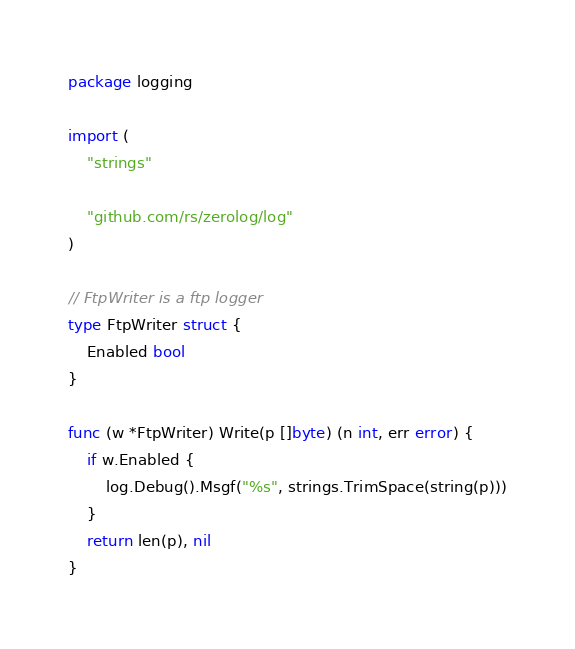<code> <loc_0><loc_0><loc_500><loc_500><_Go_>package logging

import (
	"strings"

	"github.com/rs/zerolog/log"
)

// FtpWriter is a ftp logger
type FtpWriter struct {
	Enabled bool
}

func (w *FtpWriter) Write(p []byte) (n int, err error) {
	if w.Enabled {
		log.Debug().Msgf("%s", strings.TrimSpace(string(p)))
	}
	return len(p), nil
}
</code> 